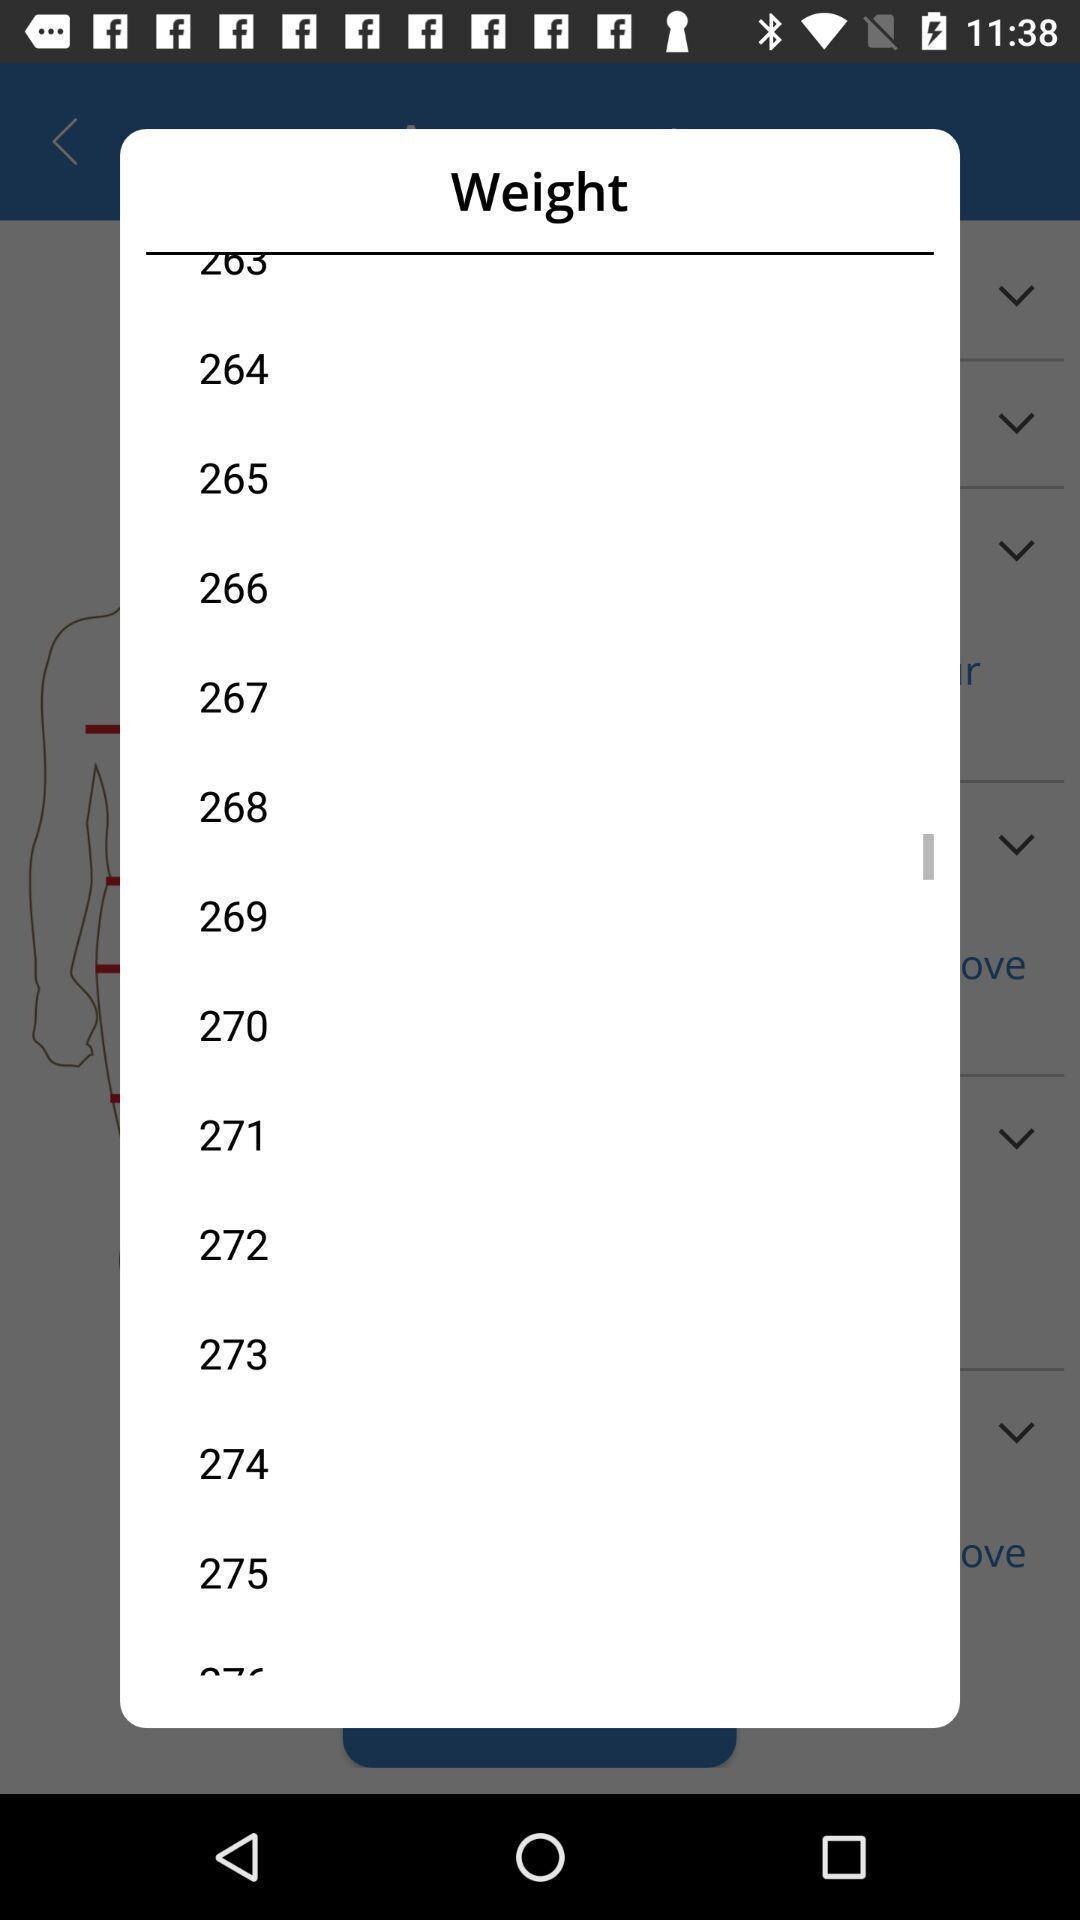Give me a narrative description of this picture. Pop-up to select the weight. 